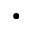Convert formula to latex. <formula><loc_0><loc_0><loc_500><loc_500>\bullet</formula> 